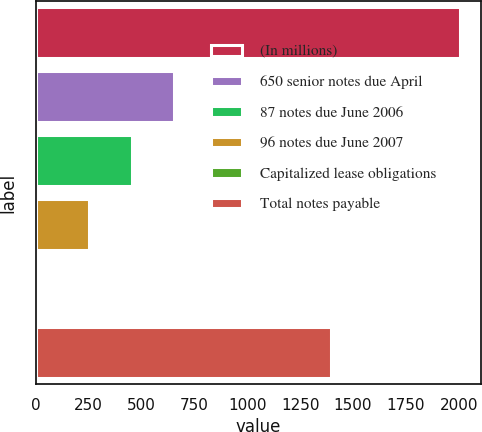Convert chart to OTSL. <chart><loc_0><loc_0><loc_500><loc_500><bar_chart><fcel>(In millions)<fcel>650 senior notes due April<fcel>87 notes due June 2006<fcel>96 notes due June 2007<fcel>Capitalized lease obligations<fcel>Total notes payable<nl><fcel>2005<fcel>652.4<fcel>453.2<fcel>254<fcel>13<fcel>1395<nl></chart> 